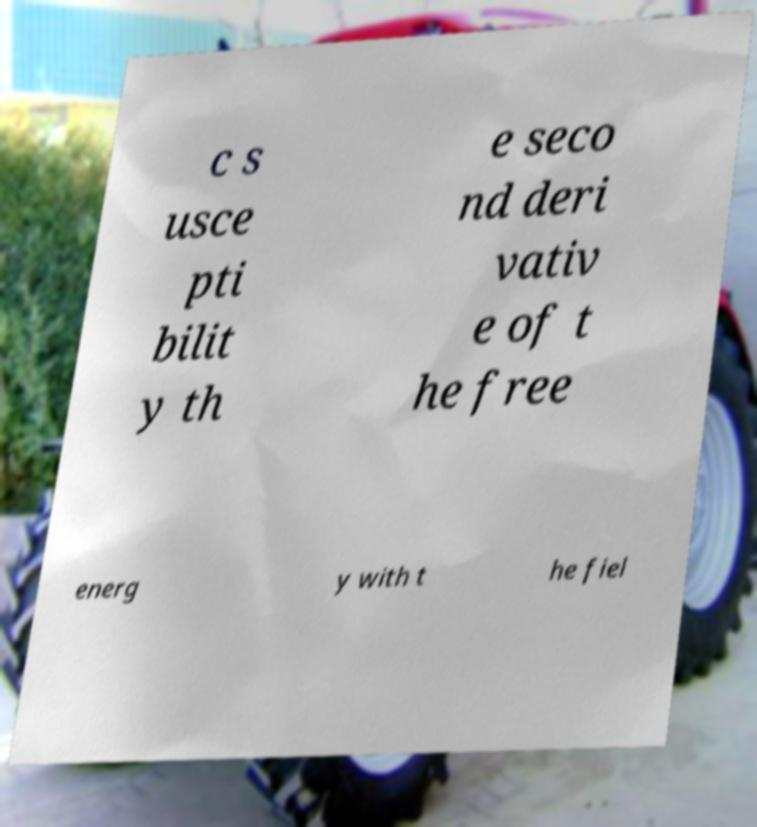Can you accurately transcribe the text from the provided image for me? c s usce pti bilit y th e seco nd deri vativ e of t he free energ y with t he fiel 